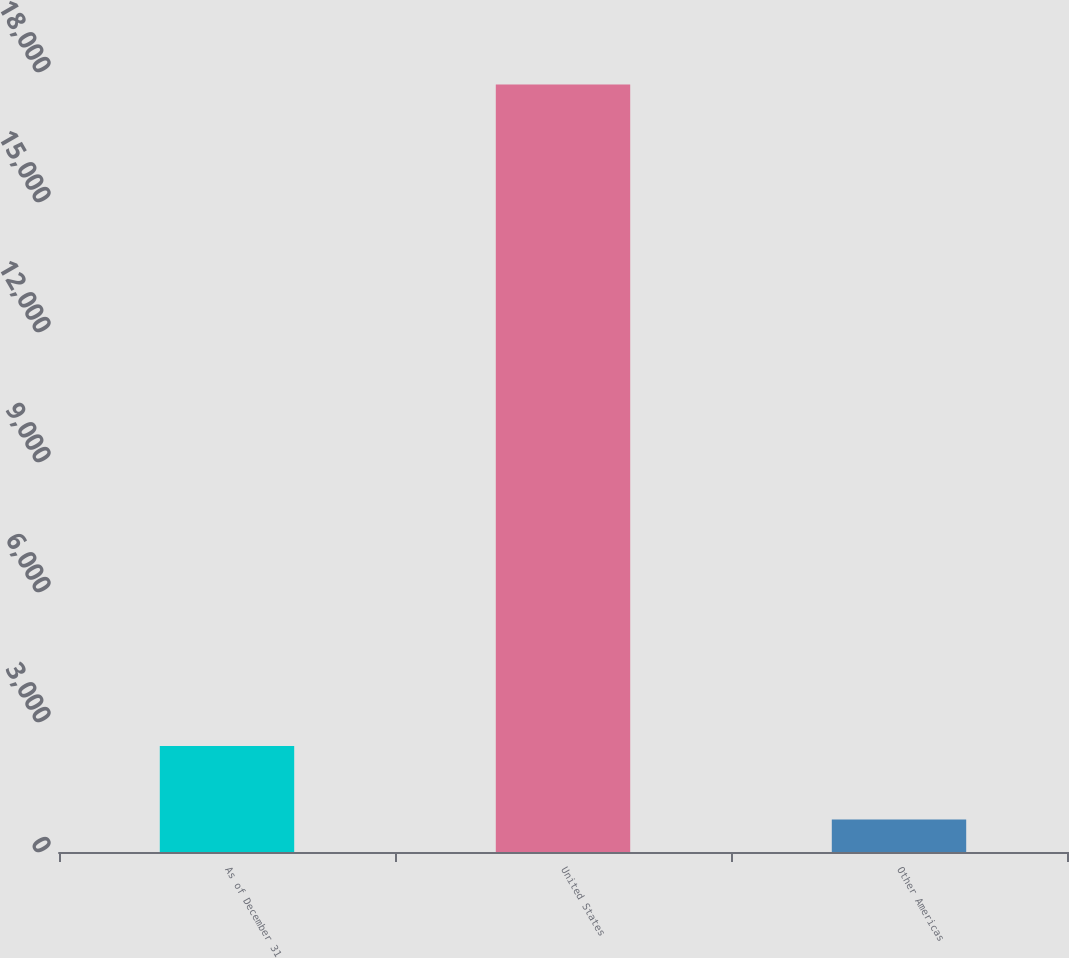Convert chart to OTSL. <chart><loc_0><loc_0><loc_500><loc_500><bar_chart><fcel>As of December 31<fcel>United States<fcel>Other Americas<nl><fcel>2447.9<fcel>17711<fcel>752<nl></chart> 